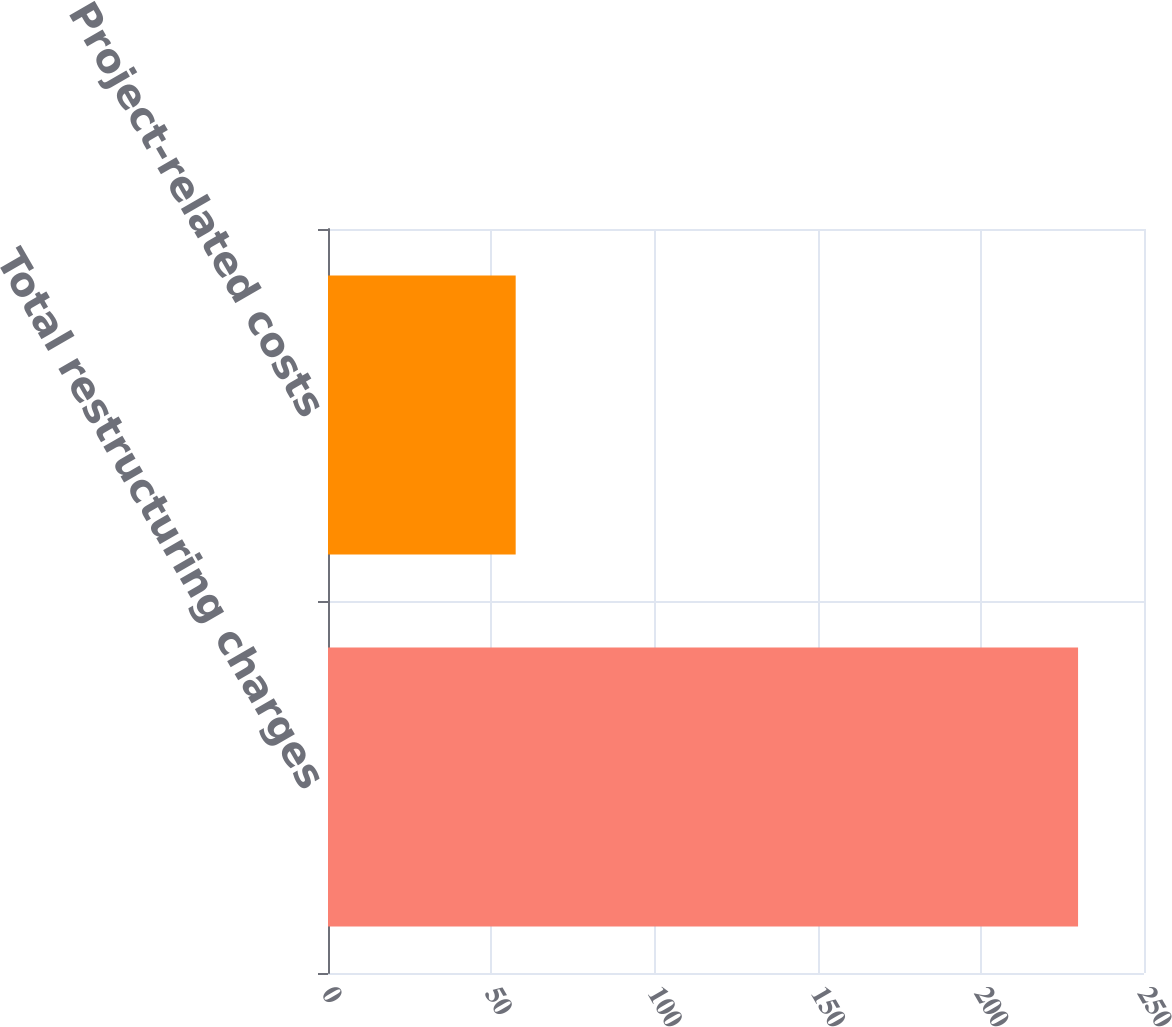Convert chart. <chart><loc_0><loc_0><loc_500><loc_500><bar_chart><fcel>Total restructuring charges<fcel>Project-related costs<nl><fcel>229.8<fcel>57.5<nl></chart> 